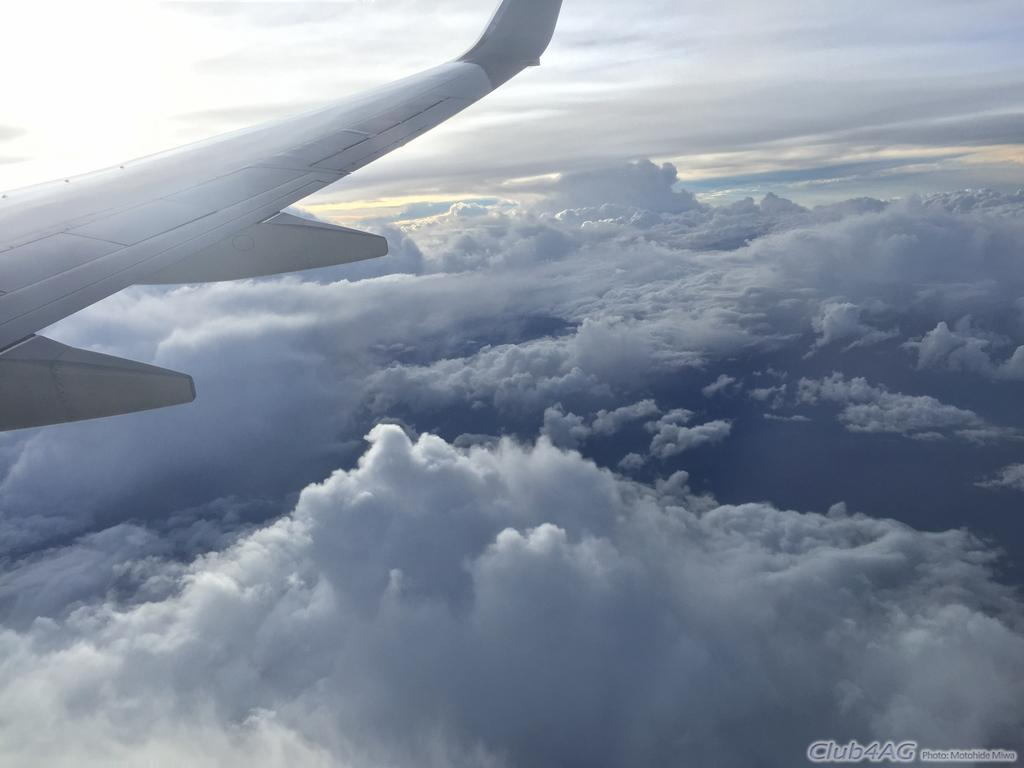What is the main subject on the left side of the image? There is an airplane on the left side of the image. What can be seen in the background of the image? The sky and clouds are visible in the background of the image. Where is the text located in the image? The text is at the right bottom of the image. How many children are playing with a rifle in the image? There are no children or rifles present in the image. 